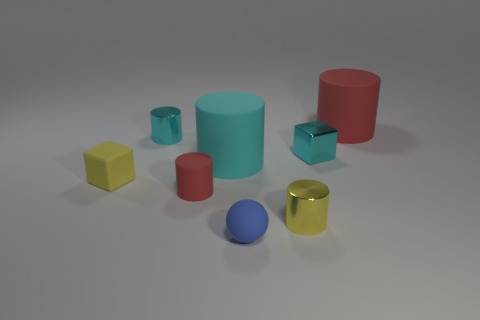Subtract 2 cylinders. How many cylinders are left? 3 Subtract all yellow cylinders. How many cylinders are left? 4 Subtract all large cyan cylinders. How many cylinders are left? 4 Subtract all yellow cylinders. Subtract all purple balls. How many cylinders are left? 4 Add 2 yellow matte cubes. How many objects exist? 10 Subtract all cylinders. How many objects are left? 3 Add 2 blocks. How many blocks are left? 4 Add 7 tiny gray matte objects. How many tiny gray matte objects exist? 7 Subtract 0 green balls. How many objects are left? 8 Subtract all small red spheres. Subtract all tiny yellow metallic things. How many objects are left? 7 